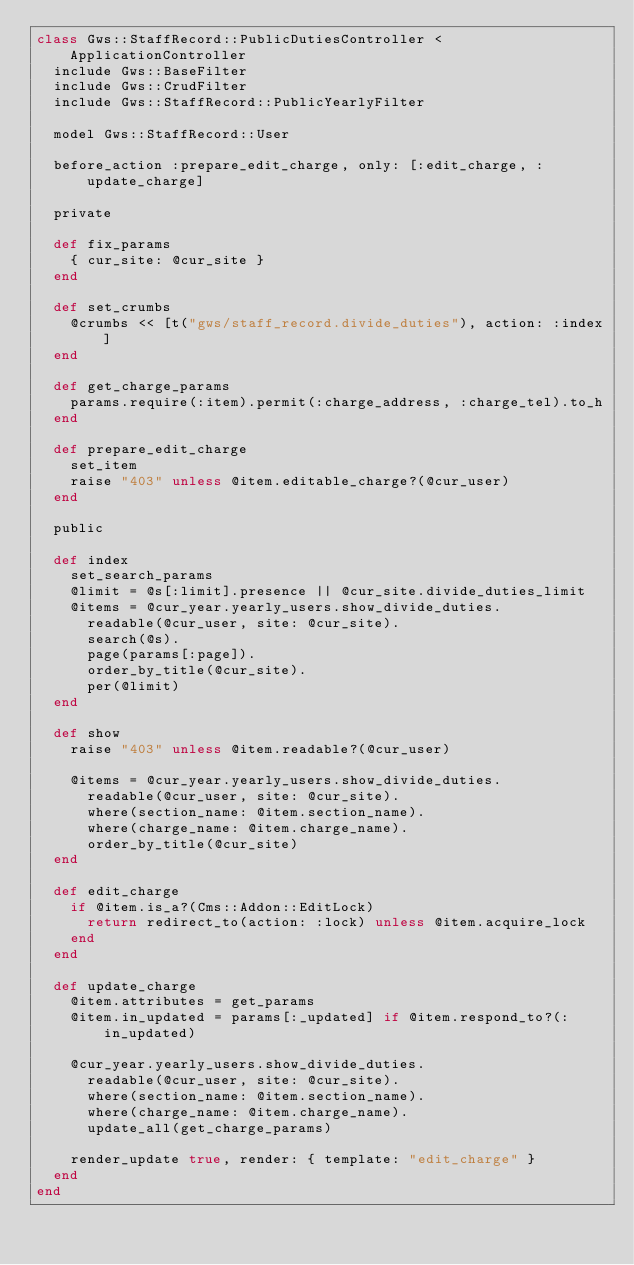Convert code to text. <code><loc_0><loc_0><loc_500><loc_500><_Ruby_>class Gws::StaffRecord::PublicDutiesController < ApplicationController
  include Gws::BaseFilter
  include Gws::CrudFilter
  include Gws::StaffRecord::PublicYearlyFilter

  model Gws::StaffRecord::User

  before_action :prepare_edit_charge, only: [:edit_charge, :update_charge]

  private

  def fix_params
    { cur_site: @cur_site }
  end

  def set_crumbs
    @crumbs << [t("gws/staff_record.divide_duties"), action: :index]
  end

  def get_charge_params
    params.require(:item).permit(:charge_address, :charge_tel).to_h
  end

  def prepare_edit_charge
    set_item
    raise "403" unless @item.editable_charge?(@cur_user)
  end

  public

  def index
    set_search_params
    @limit = @s[:limit].presence || @cur_site.divide_duties_limit
    @items = @cur_year.yearly_users.show_divide_duties.
      readable(@cur_user, site: @cur_site).
      search(@s).
      page(params[:page]).
      order_by_title(@cur_site).
      per(@limit)
  end

  def show
    raise "403" unless @item.readable?(@cur_user)

    @items = @cur_year.yearly_users.show_divide_duties.
      readable(@cur_user, site: @cur_site).
      where(section_name: @item.section_name).
      where(charge_name: @item.charge_name).
      order_by_title(@cur_site)
  end

  def edit_charge
    if @item.is_a?(Cms::Addon::EditLock)
      return redirect_to(action: :lock) unless @item.acquire_lock
    end
  end

  def update_charge
    @item.attributes = get_params
    @item.in_updated = params[:_updated] if @item.respond_to?(:in_updated)

    @cur_year.yearly_users.show_divide_duties.
      readable(@cur_user, site: @cur_site).
      where(section_name: @item.section_name).
      where(charge_name: @item.charge_name).
      update_all(get_charge_params)

    render_update true, render: { template: "edit_charge" }
  end
end
</code> 